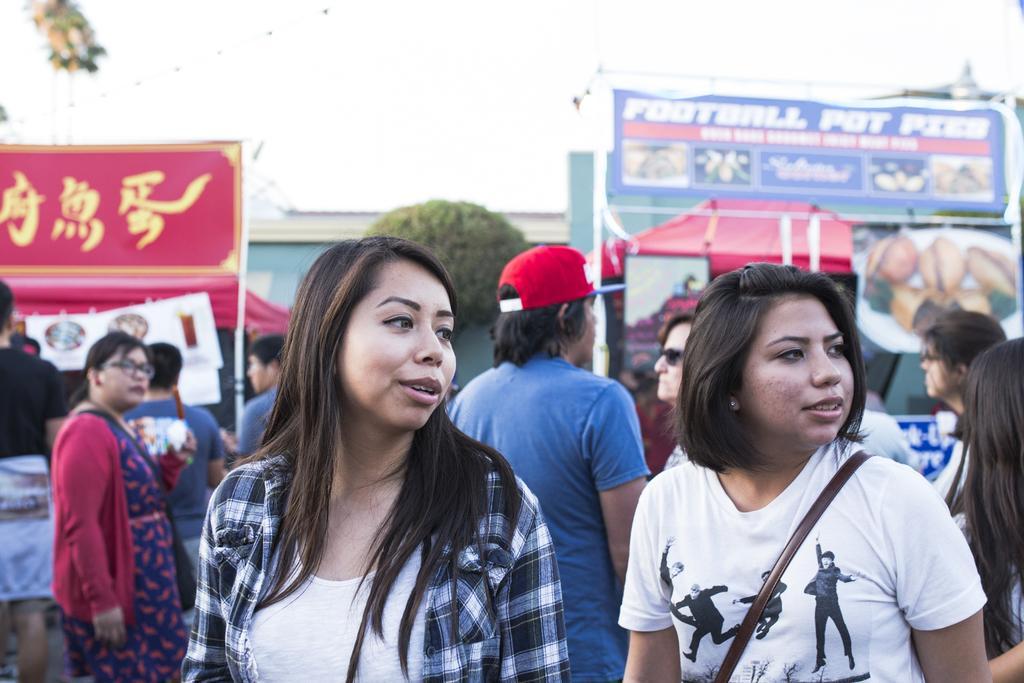How would you summarize this image in a sentence or two? In this image we can see the few people, there are some stalls and written text on the board, near there are trees, we can see the sky in the background. 